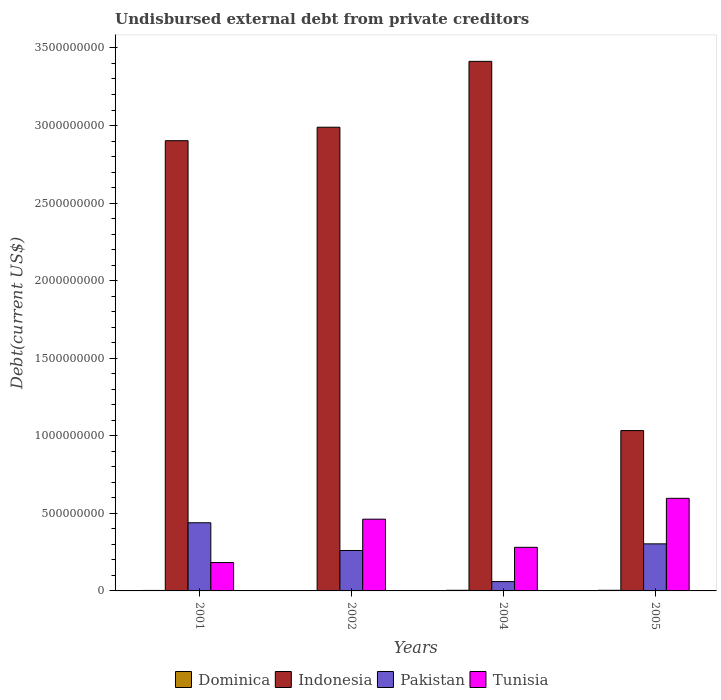How many different coloured bars are there?
Offer a terse response. 4. Are the number of bars per tick equal to the number of legend labels?
Your answer should be very brief. Yes. How many bars are there on the 3rd tick from the left?
Offer a terse response. 4. How many bars are there on the 4th tick from the right?
Your answer should be very brief. 4. What is the label of the 1st group of bars from the left?
Your answer should be very brief. 2001. What is the total debt in Pakistan in 2004?
Your answer should be compact. 6.01e+07. Across all years, what is the maximum total debt in Indonesia?
Keep it short and to the point. 3.41e+09. Across all years, what is the minimum total debt in Dominica?
Offer a terse response. 1.44e+06. In which year was the total debt in Indonesia maximum?
Ensure brevity in your answer.  2004. What is the total total debt in Dominica in the graph?
Provide a short and direct response. 1.28e+07. What is the difference between the total debt in Tunisia in 2001 and that in 2004?
Offer a terse response. -9.81e+07. What is the difference between the total debt in Pakistan in 2002 and the total debt in Indonesia in 2004?
Offer a terse response. -3.15e+09. What is the average total debt in Dominica per year?
Offer a terse response. 3.21e+06. In the year 2005, what is the difference between the total debt in Pakistan and total debt in Dominica?
Your response must be concise. 2.99e+08. In how many years, is the total debt in Tunisia greater than 2200000000 US$?
Keep it short and to the point. 0. What is the ratio of the total debt in Pakistan in 2002 to that in 2004?
Ensure brevity in your answer.  4.34. Is the total debt in Pakistan in 2002 less than that in 2004?
Offer a terse response. No. Is the difference between the total debt in Pakistan in 2001 and 2005 greater than the difference between the total debt in Dominica in 2001 and 2005?
Your answer should be compact. Yes. What is the difference between the highest and the second highest total debt in Tunisia?
Your response must be concise. 1.34e+08. What is the difference between the highest and the lowest total debt in Pakistan?
Give a very brief answer. 3.79e+08. In how many years, is the total debt in Dominica greater than the average total debt in Dominica taken over all years?
Offer a very short reply. 2. What does the 2nd bar from the left in 2004 represents?
Keep it short and to the point. Indonesia. What does the 1st bar from the right in 2001 represents?
Keep it short and to the point. Tunisia. Is it the case that in every year, the sum of the total debt in Dominica and total debt in Tunisia is greater than the total debt in Pakistan?
Make the answer very short. No. How many bars are there?
Offer a terse response. 16. Are all the bars in the graph horizontal?
Provide a short and direct response. No. What is the difference between two consecutive major ticks on the Y-axis?
Your answer should be very brief. 5.00e+08. Does the graph contain grids?
Make the answer very short. No. What is the title of the graph?
Make the answer very short. Undisbursed external debt from private creditors. What is the label or title of the Y-axis?
Make the answer very short. Debt(current US$). What is the Debt(current US$) of Dominica in 2001?
Your answer should be compact. 3.20e+06. What is the Debt(current US$) of Indonesia in 2001?
Give a very brief answer. 2.90e+09. What is the Debt(current US$) of Pakistan in 2001?
Your answer should be very brief. 4.39e+08. What is the Debt(current US$) of Tunisia in 2001?
Ensure brevity in your answer.  1.83e+08. What is the Debt(current US$) of Dominica in 2002?
Provide a succinct answer. 1.44e+06. What is the Debt(current US$) of Indonesia in 2002?
Offer a terse response. 2.99e+09. What is the Debt(current US$) in Pakistan in 2002?
Give a very brief answer. 2.61e+08. What is the Debt(current US$) in Tunisia in 2002?
Give a very brief answer. 4.62e+08. What is the Debt(current US$) of Dominica in 2004?
Your response must be concise. 4.12e+06. What is the Debt(current US$) in Indonesia in 2004?
Make the answer very short. 3.41e+09. What is the Debt(current US$) of Pakistan in 2004?
Your answer should be very brief. 6.01e+07. What is the Debt(current US$) of Tunisia in 2004?
Your answer should be compact. 2.81e+08. What is the Debt(current US$) in Dominica in 2005?
Provide a succinct answer. 4.08e+06. What is the Debt(current US$) of Indonesia in 2005?
Provide a succinct answer. 1.03e+09. What is the Debt(current US$) of Pakistan in 2005?
Provide a short and direct response. 3.03e+08. What is the Debt(current US$) of Tunisia in 2005?
Offer a very short reply. 5.97e+08. Across all years, what is the maximum Debt(current US$) of Dominica?
Your answer should be very brief. 4.12e+06. Across all years, what is the maximum Debt(current US$) of Indonesia?
Provide a short and direct response. 3.41e+09. Across all years, what is the maximum Debt(current US$) in Pakistan?
Your answer should be compact. 4.39e+08. Across all years, what is the maximum Debt(current US$) in Tunisia?
Your answer should be very brief. 5.97e+08. Across all years, what is the minimum Debt(current US$) in Dominica?
Your response must be concise. 1.44e+06. Across all years, what is the minimum Debt(current US$) of Indonesia?
Ensure brevity in your answer.  1.03e+09. Across all years, what is the minimum Debt(current US$) in Pakistan?
Provide a short and direct response. 6.01e+07. Across all years, what is the minimum Debt(current US$) of Tunisia?
Make the answer very short. 1.83e+08. What is the total Debt(current US$) in Dominica in the graph?
Your answer should be compact. 1.28e+07. What is the total Debt(current US$) in Indonesia in the graph?
Your response must be concise. 1.03e+1. What is the total Debt(current US$) in Pakistan in the graph?
Your answer should be very brief. 1.06e+09. What is the total Debt(current US$) of Tunisia in the graph?
Offer a very short reply. 1.52e+09. What is the difference between the Debt(current US$) in Dominica in 2001 and that in 2002?
Offer a terse response. 1.76e+06. What is the difference between the Debt(current US$) of Indonesia in 2001 and that in 2002?
Offer a very short reply. -8.68e+07. What is the difference between the Debt(current US$) of Pakistan in 2001 and that in 2002?
Your answer should be very brief. 1.79e+08. What is the difference between the Debt(current US$) in Tunisia in 2001 and that in 2002?
Offer a terse response. -2.80e+08. What is the difference between the Debt(current US$) of Dominica in 2001 and that in 2004?
Provide a succinct answer. -9.12e+05. What is the difference between the Debt(current US$) in Indonesia in 2001 and that in 2004?
Give a very brief answer. -5.11e+08. What is the difference between the Debt(current US$) in Pakistan in 2001 and that in 2004?
Keep it short and to the point. 3.79e+08. What is the difference between the Debt(current US$) of Tunisia in 2001 and that in 2004?
Your answer should be compact. -9.81e+07. What is the difference between the Debt(current US$) in Dominica in 2001 and that in 2005?
Your answer should be very brief. -8.75e+05. What is the difference between the Debt(current US$) of Indonesia in 2001 and that in 2005?
Offer a terse response. 1.87e+09. What is the difference between the Debt(current US$) of Pakistan in 2001 and that in 2005?
Give a very brief answer. 1.36e+08. What is the difference between the Debt(current US$) in Tunisia in 2001 and that in 2005?
Ensure brevity in your answer.  -4.14e+08. What is the difference between the Debt(current US$) in Dominica in 2002 and that in 2004?
Offer a terse response. -2.68e+06. What is the difference between the Debt(current US$) in Indonesia in 2002 and that in 2004?
Give a very brief answer. -4.25e+08. What is the difference between the Debt(current US$) of Pakistan in 2002 and that in 2004?
Provide a succinct answer. 2.00e+08. What is the difference between the Debt(current US$) in Tunisia in 2002 and that in 2004?
Your response must be concise. 1.81e+08. What is the difference between the Debt(current US$) in Dominica in 2002 and that in 2005?
Offer a very short reply. -2.64e+06. What is the difference between the Debt(current US$) of Indonesia in 2002 and that in 2005?
Your answer should be very brief. 1.96e+09. What is the difference between the Debt(current US$) in Pakistan in 2002 and that in 2005?
Your answer should be compact. -4.28e+07. What is the difference between the Debt(current US$) of Tunisia in 2002 and that in 2005?
Provide a succinct answer. -1.34e+08. What is the difference between the Debt(current US$) in Dominica in 2004 and that in 2005?
Your answer should be compact. 3.70e+04. What is the difference between the Debt(current US$) of Indonesia in 2004 and that in 2005?
Your answer should be compact. 2.38e+09. What is the difference between the Debt(current US$) in Pakistan in 2004 and that in 2005?
Your response must be concise. -2.43e+08. What is the difference between the Debt(current US$) of Tunisia in 2004 and that in 2005?
Your answer should be very brief. -3.16e+08. What is the difference between the Debt(current US$) in Dominica in 2001 and the Debt(current US$) in Indonesia in 2002?
Make the answer very short. -2.99e+09. What is the difference between the Debt(current US$) in Dominica in 2001 and the Debt(current US$) in Pakistan in 2002?
Provide a short and direct response. -2.57e+08. What is the difference between the Debt(current US$) in Dominica in 2001 and the Debt(current US$) in Tunisia in 2002?
Your answer should be very brief. -4.59e+08. What is the difference between the Debt(current US$) in Indonesia in 2001 and the Debt(current US$) in Pakistan in 2002?
Your answer should be very brief. 2.64e+09. What is the difference between the Debt(current US$) of Indonesia in 2001 and the Debt(current US$) of Tunisia in 2002?
Keep it short and to the point. 2.44e+09. What is the difference between the Debt(current US$) of Pakistan in 2001 and the Debt(current US$) of Tunisia in 2002?
Provide a short and direct response. -2.31e+07. What is the difference between the Debt(current US$) of Dominica in 2001 and the Debt(current US$) of Indonesia in 2004?
Ensure brevity in your answer.  -3.41e+09. What is the difference between the Debt(current US$) of Dominica in 2001 and the Debt(current US$) of Pakistan in 2004?
Provide a short and direct response. -5.69e+07. What is the difference between the Debt(current US$) of Dominica in 2001 and the Debt(current US$) of Tunisia in 2004?
Your response must be concise. -2.78e+08. What is the difference between the Debt(current US$) in Indonesia in 2001 and the Debt(current US$) in Pakistan in 2004?
Your response must be concise. 2.84e+09. What is the difference between the Debt(current US$) in Indonesia in 2001 and the Debt(current US$) in Tunisia in 2004?
Provide a succinct answer. 2.62e+09. What is the difference between the Debt(current US$) in Pakistan in 2001 and the Debt(current US$) in Tunisia in 2004?
Give a very brief answer. 1.58e+08. What is the difference between the Debt(current US$) in Dominica in 2001 and the Debt(current US$) in Indonesia in 2005?
Give a very brief answer. -1.03e+09. What is the difference between the Debt(current US$) of Dominica in 2001 and the Debt(current US$) of Pakistan in 2005?
Your answer should be very brief. -3.00e+08. What is the difference between the Debt(current US$) of Dominica in 2001 and the Debt(current US$) of Tunisia in 2005?
Keep it short and to the point. -5.94e+08. What is the difference between the Debt(current US$) of Indonesia in 2001 and the Debt(current US$) of Pakistan in 2005?
Your response must be concise. 2.60e+09. What is the difference between the Debt(current US$) in Indonesia in 2001 and the Debt(current US$) in Tunisia in 2005?
Your answer should be very brief. 2.31e+09. What is the difference between the Debt(current US$) of Pakistan in 2001 and the Debt(current US$) of Tunisia in 2005?
Your response must be concise. -1.58e+08. What is the difference between the Debt(current US$) in Dominica in 2002 and the Debt(current US$) in Indonesia in 2004?
Provide a short and direct response. -3.41e+09. What is the difference between the Debt(current US$) in Dominica in 2002 and the Debt(current US$) in Pakistan in 2004?
Ensure brevity in your answer.  -5.87e+07. What is the difference between the Debt(current US$) in Dominica in 2002 and the Debt(current US$) in Tunisia in 2004?
Keep it short and to the point. -2.80e+08. What is the difference between the Debt(current US$) of Indonesia in 2002 and the Debt(current US$) of Pakistan in 2004?
Provide a short and direct response. 2.93e+09. What is the difference between the Debt(current US$) in Indonesia in 2002 and the Debt(current US$) in Tunisia in 2004?
Your answer should be compact. 2.71e+09. What is the difference between the Debt(current US$) of Pakistan in 2002 and the Debt(current US$) of Tunisia in 2004?
Keep it short and to the point. -2.04e+07. What is the difference between the Debt(current US$) in Dominica in 2002 and the Debt(current US$) in Indonesia in 2005?
Make the answer very short. -1.03e+09. What is the difference between the Debt(current US$) of Dominica in 2002 and the Debt(current US$) of Pakistan in 2005?
Your response must be concise. -3.02e+08. What is the difference between the Debt(current US$) in Dominica in 2002 and the Debt(current US$) in Tunisia in 2005?
Keep it short and to the point. -5.95e+08. What is the difference between the Debt(current US$) in Indonesia in 2002 and the Debt(current US$) in Pakistan in 2005?
Offer a terse response. 2.69e+09. What is the difference between the Debt(current US$) in Indonesia in 2002 and the Debt(current US$) in Tunisia in 2005?
Your answer should be very brief. 2.39e+09. What is the difference between the Debt(current US$) in Pakistan in 2002 and the Debt(current US$) in Tunisia in 2005?
Offer a very short reply. -3.36e+08. What is the difference between the Debt(current US$) of Dominica in 2004 and the Debt(current US$) of Indonesia in 2005?
Provide a succinct answer. -1.03e+09. What is the difference between the Debt(current US$) in Dominica in 2004 and the Debt(current US$) in Pakistan in 2005?
Your answer should be very brief. -2.99e+08. What is the difference between the Debt(current US$) in Dominica in 2004 and the Debt(current US$) in Tunisia in 2005?
Make the answer very short. -5.93e+08. What is the difference between the Debt(current US$) in Indonesia in 2004 and the Debt(current US$) in Pakistan in 2005?
Your answer should be compact. 3.11e+09. What is the difference between the Debt(current US$) of Indonesia in 2004 and the Debt(current US$) of Tunisia in 2005?
Make the answer very short. 2.82e+09. What is the difference between the Debt(current US$) of Pakistan in 2004 and the Debt(current US$) of Tunisia in 2005?
Your answer should be very brief. -5.37e+08. What is the average Debt(current US$) of Dominica per year?
Offer a terse response. 3.21e+06. What is the average Debt(current US$) in Indonesia per year?
Give a very brief answer. 2.58e+09. What is the average Debt(current US$) of Pakistan per year?
Keep it short and to the point. 2.66e+08. What is the average Debt(current US$) in Tunisia per year?
Offer a very short reply. 3.81e+08. In the year 2001, what is the difference between the Debt(current US$) in Dominica and Debt(current US$) in Indonesia?
Provide a succinct answer. -2.90e+09. In the year 2001, what is the difference between the Debt(current US$) in Dominica and Debt(current US$) in Pakistan?
Offer a very short reply. -4.36e+08. In the year 2001, what is the difference between the Debt(current US$) of Dominica and Debt(current US$) of Tunisia?
Make the answer very short. -1.80e+08. In the year 2001, what is the difference between the Debt(current US$) in Indonesia and Debt(current US$) in Pakistan?
Provide a succinct answer. 2.46e+09. In the year 2001, what is the difference between the Debt(current US$) of Indonesia and Debt(current US$) of Tunisia?
Provide a succinct answer. 2.72e+09. In the year 2001, what is the difference between the Debt(current US$) of Pakistan and Debt(current US$) of Tunisia?
Make the answer very short. 2.57e+08. In the year 2002, what is the difference between the Debt(current US$) of Dominica and Debt(current US$) of Indonesia?
Your answer should be very brief. -2.99e+09. In the year 2002, what is the difference between the Debt(current US$) of Dominica and Debt(current US$) of Pakistan?
Provide a short and direct response. -2.59e+08. In the year 2002, what is the difference between the Debt(current US$) of Dominica and Debt(current US$) of Tunisia?
Provide a short and direct response. -4.61e+08. In the year 2002, what is the difference between the Debt(current US$) in Indonesia and Debt(current US$) in Pakistan?
Your answer should be compact. 2.73e+09. In the year 2002, what is the difference between the Debt(current US$) in Indonesia and Debt(current US$) in Tunisia?
Keep it short and to the point. 2.53e+09. In the year 2002, what is the difference between the Debt(current US$) of Pakistan and Debt(current US$) of Tunisia?
Provide a succinct answer. -2.02e+08. In the year 2004, what is the difference between the Debt(current US$) in Dominica and Debt(current US$) in Indonesia?
Offer a very short reply. -3.41e+09. In the year 2004, what is the difference between the Debt(current US$) in Dominica and Debt(current US$) in Pakistan?
Offer a terse response. -5.60e+07. In the year 2004, what is the difference between the Debt(current US$) in Dominica and Debt(current US$) in Tunisia?
Offer a very short reply. -2.77e+08. In the year 2004, what is the difference between the Debt(current US$) in Indonesia and Debt(current US$) in Pakistan?
Make the answer very short. 3.35e+09. In the year 2004, what is the difference between the Debt(current US$) in Indonesia and Debt(current US$) in Tunisia?
Ensure brevity in your answer.  3.13e+09. In the year 2004, what is the difference between the Debt(current US$) in Pakistan and Debt(current US$) in Tunisia?
Provide a succinct answer. -2.21e+08. In the year 2005, what is the difference between the Debt(current US$) of Dominica and Debt(current US$) of Indonesia?
Your answer should be compact. -1.03e+09. In the year 2005, what is the difference between the Debt(current US$) of Dominica and Debt(current US$) of Pakistan?
Offer a very short reply. -2.99e+08. In the year 2005, what is the difference between the Debt(current US$) of Dominica and Debt(current US$) of Tunisia?
Offer a very short reply. -5.93e+08. In the year 2005, what is the difference between the Debt(current US$) of Indonesia and Debt(current US$) of Pakistan?
Your response must be concise. 7.30e+08. In the year 2005, what is the difference between the Debt(current US$) in Indonesia and Debt(current US$) in Tunisia?
Offer a terse response. 4.37e+08. In the year 2005, what is the difference between the Debt(current US$) in Pakistan and Debt(current US$) in Tunisia?
Offer a very short reply. -2.94e+08. What is the ratio of the Debt(current US$) of Dominica in 2001 to that in 2002?
Give a very brief answer. 2.22. What is the ratio of the Debt(current US$) in Indonesia in 2001 to that in 2002?
Offer a very short reply. 0.97. What is the ratio of the Debt(current US$) in Pakistan in 2001 to that in 2002?
Your answer should be very brief. 1.69. What is the ratio of the Debt(current US$) in Tunisia in 2001 to that in 2002?
Make the answer very short. 0.4. What is the ratio of the Debt(current US$) in Dominica in 2001 to that in 2004?
Offer a very short reply. 0.78. What is the ratio of the Debt(current US$) of Indonesia in 2001 to that in 2004?
Provide a succinct answer. 0.85. What is the ratio of the Debt(current US$) of Pakistan in 2001 to that in 2004?
Keep it short and to the point. 7.31. What is the ratio of the Debt(current US$) in Tunisia in 2001 to that in 2004?
Provide a short and direct response. 0.65. What is the ratio of the Debt(current US$) in Dominica in 2001 to that in 2005?
Your answer should be compact. 0.79. What is the ratio of the Debt(current US$) in Indonesia in 2001 to that in 2005?
Your answer should be very brief. 2.81. What is the ratio of the Debt(current US$) of Pakistan in 2001 to that in 2005?
Provide a succinct answer. 1.45. What is the ratio of the Debt(current US$) in Tunisia in 2001 to that in 2005?
Ensure brevity in your answer.  0.31. What is the ratio of the Debt(current US$) of Dominica in 2002 to that in 2004?
Make the answer very short. 0.35. What is the ratio of the Debt(current US$) of Indonesia in 2002 to that in 2004?
Your answer should be compact. 0.88. What is the ratio of the Debt(current US$) in Pakistan in 2002 to that in 2004?
Your response must be concise. 4.34. What is the ratio of the Debt(current US$) in Tunisia in 2002 to that in 2004?
Provide a succinct answer. 1.65. What is the ratio of the Debt(current US$) of Dominica in 2002 to that in 2005?
Ensure brevity in your answer.  0.35. What is the ratio of the Debt(current US$) in Indonesia in 2002 to that in 2005?
Give a very brief answer. 2.89. What is the ratio of the Debt(current US$) in Pakistan in 2002 to that in 2005?
Make the answer very short. 0.86. What is the ratio of the Debt(current US$) of Tunisia in 2002 to that in 2005?
Provide a succinct answer. 0.77. What is the ratio of the Debt(current US$) in Dominica in 2004 to that in 2005?
Your answer should be very brief. 1.01. What is the ratio of the Debt(current US$) in Indonesia in 2004 to that in 2005?
Ensure brevity in your answer.  3.3. What is the ratio of the Debt(current US$) in Pakistan in 2004 to that in 2005?
Make the answer very short. 0.2. What is the ratio of the Debt(current US$) of Tunisia in 2004 to that in 2005?
Your answer should be very brief. 0.47. What is the difference between the highest and the second highest Debt(current US$) of Dominica?
Make the answer very short. 3.70e+04. What is the difference between the highest and the second highest Debt(current US$) in Indonesia?
Keep it short and to the point. 4.25e+08. What is the difference between the highest and the second highest Debt(current US$) in Pakistan?
Provide a short and direct response. 1.36e+08. What is the difference between the highest and the second highest Debt(current US$) in Tunisia?
Your answer should be compact. 1.34e+08. What is the difference between the highest and the lowest Debt(current US$) of Dominica?
Your answer should be very brief. 2.68e+06. What is the difference between the highest and the lowest Debt(current US$) in Indonesia?
Ensure brevity in your answer.  2.38e+09. What is the difference between the highest and the lowest Debt(current US$) of Pakistan?
Keep it short and to the point. 3.79e+08. What is the difference between the highest and the lowest Debt(current US$) in Tunisia?
Offer a terse response. 4.14e+08. 